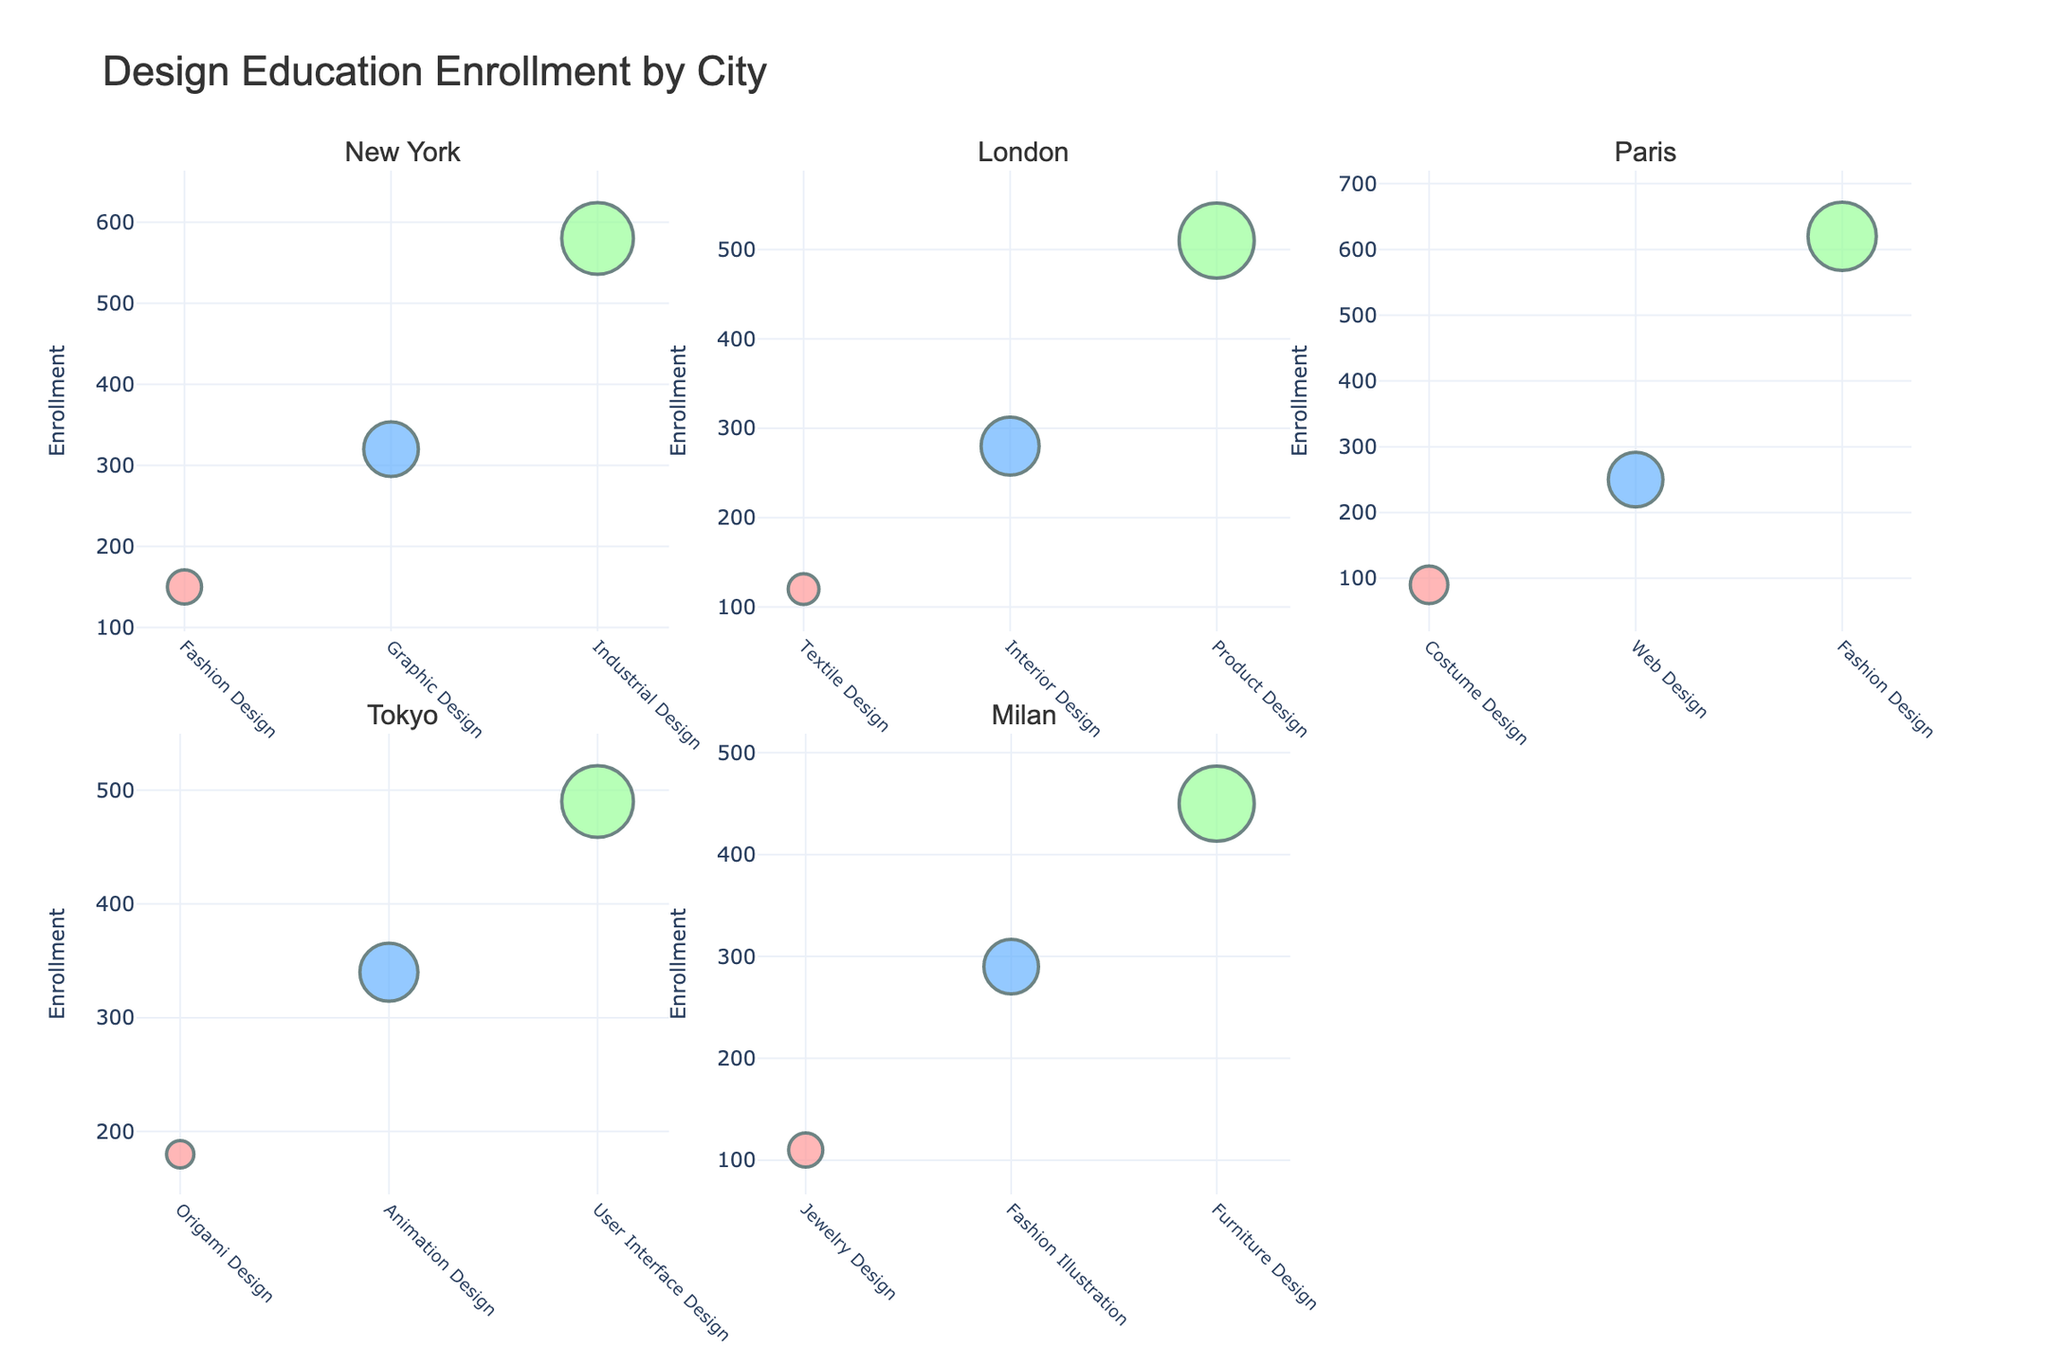What is the title of the chart? The title is located at the top of the figure and reads "Design Education Enrollment by City."
Answer: Design Education Enrollment by City How many major cities are represented in the figure? The subplot titles indicate the number of major cities represented in the figure. There are six subplots, each with a different city name.
Answer: Six Which design discipline in Paris for University has the highest enrollment? In the Paris subplot, the bubble chart for University shows that Fashion Design has the largest bubble.
Answer: Fashion Design What color represents Elementary education levels across all cities? The bubble color indicates the education level. The bubbles for Elementary education are colored in a shade of red (#FF9999).
Answer: Red Compare the enrollment numbers between High School in New York and Tokyo for their respective design disciplines. Which one has a higher enrollment? In the New York subplot, High School (Graphic Design) has an enrollment of 320. In Tokyo, High School (Animation Design) has an enrollment of 340.
Answer: Tokyo What is the average age of students enrolled in Industrial Design at the university level in New York? The bubble for University in the New York subplot, representing Industrial Design, states the average age in its hover text.
Answer: 21 Which city has the lowest University level enrollment and in which discipline? By comparing the sizes of the bubbles at the University level in each subplot, Milan's Furniture Design appears to be the smallest bubble.
Answer: Milan, Furniture Design What is the total enrollment for all University level design disciplines in London? The enrollment numbers for London at the University level in the subplot are: Product Design (510). The total is simply 510.
Answer: 510 How does the enrollment for High School design disciplines in Milan compare to those in Paris? Comparing the bubble sizes for High School in Milan (Fashion Illustration - 290) and Paris (Web Design - 250), Milan has a larger bubble.
Answer: Milan has a higher enrollment For which city and education level do students have the youngest average age? The bubble for Elementary levels in Tokyo (Origami Design) represents the youngest average age at 8.
Answer: Tokyo, Elementary 